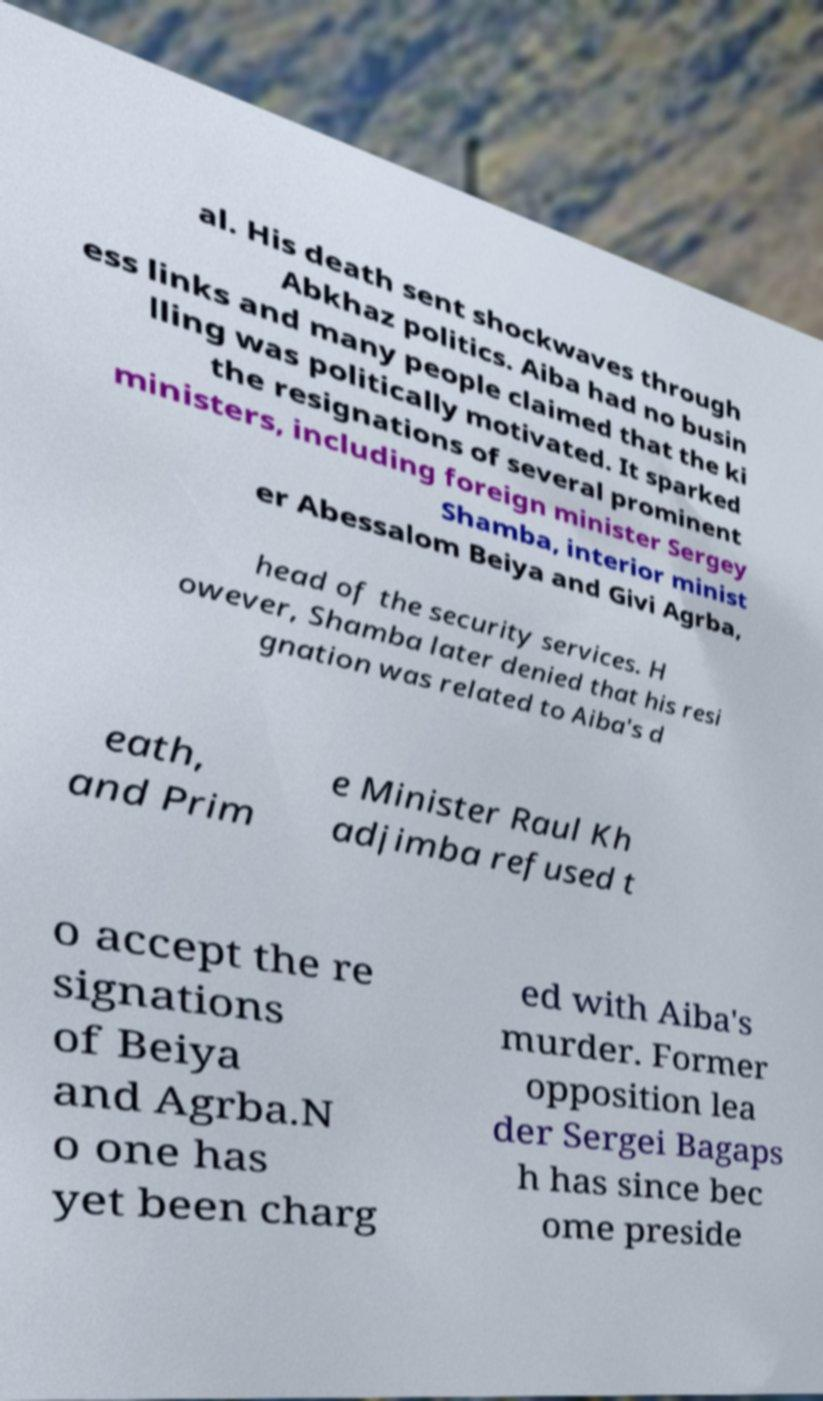There's text embedded in this image that I need extracted. Can you transcribe it verbatim? al. His death sent shockwaves through Abkhaz politics. Aiba had no busin ess links and many people claimed that the ki lling was politically motivated. It sparked the resignations of several prominent ministers, including foreign minister Sergey Shamba, interior minist er Abessalom Beiya and Givi Agrba, head of the security services. H owever, Shamba later denied that his resi gnation was related to Aiba's d eath, and Prim e Minister Raul Kh adjimba refused t o accept the re signations of Beiya and Agrba.N o one has yet been charg ed with Aiba's murder. Former opposition lea der Sergei Bagaps h has since bec ome preside 